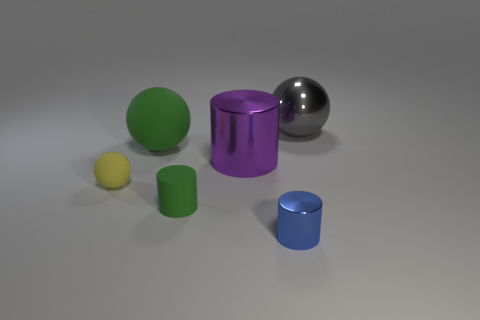Is there any other thing that has the same color as the tiny metal cylinder?
Offer a terse response. No. Are there more tiny cylinders that are in front of the tiny green thing than yellow objects on the right side of the tiny yellow matte ball?
Offer a very short reply. Yes. What shape is the blue shiny object?
Offer a terse response. Cylinder. Do the big sphere right of the blue metallic cylinder and the big purple cylinder that is behind the tiny yellow matte ball have the same material?
Ensure brevity in your answer.  Yes. What is the shape of the metallic thing in front of the small sphere?
Offer a terse response. Cylinder. What is the size of the yellow rubber object that is the same shape as the gray shiny object?
Keep it short and to the point. Small. Do the big matte sphere and the small rubber cylinder have the same color?
Your response must be concise. Yes. There is a big metal object to the left of the large gray metal thing; are there any metal objects that are in front of it?
Your answer should be very brief. Yes. What color is the tiny matte object that is the same shape as the big purple metal thing?
Ensure brevity in your answer.  Green. How many other big cylinders have the same color as the large cylinder?
Offer a terse response. 0. 